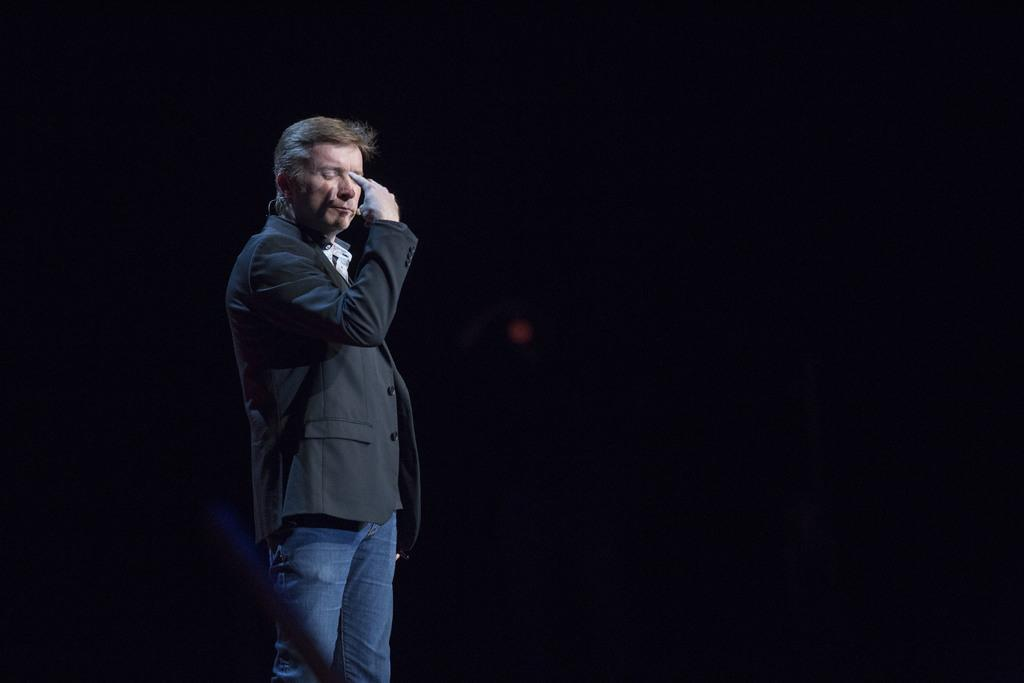Who or what is present in the image? There is a person in the image. What is the person wearing on their upper body? The person is wearing a black blazer. What type of pants is the person wearing? The person is wearing blue jeans. What is the person's posture in the image? The person is standing. What color is the background of the image? The background of the image is black. What type of learning is the monkey engaged in within the image? There is no monkey present in the image, and therefore no learning activity can be observed. 